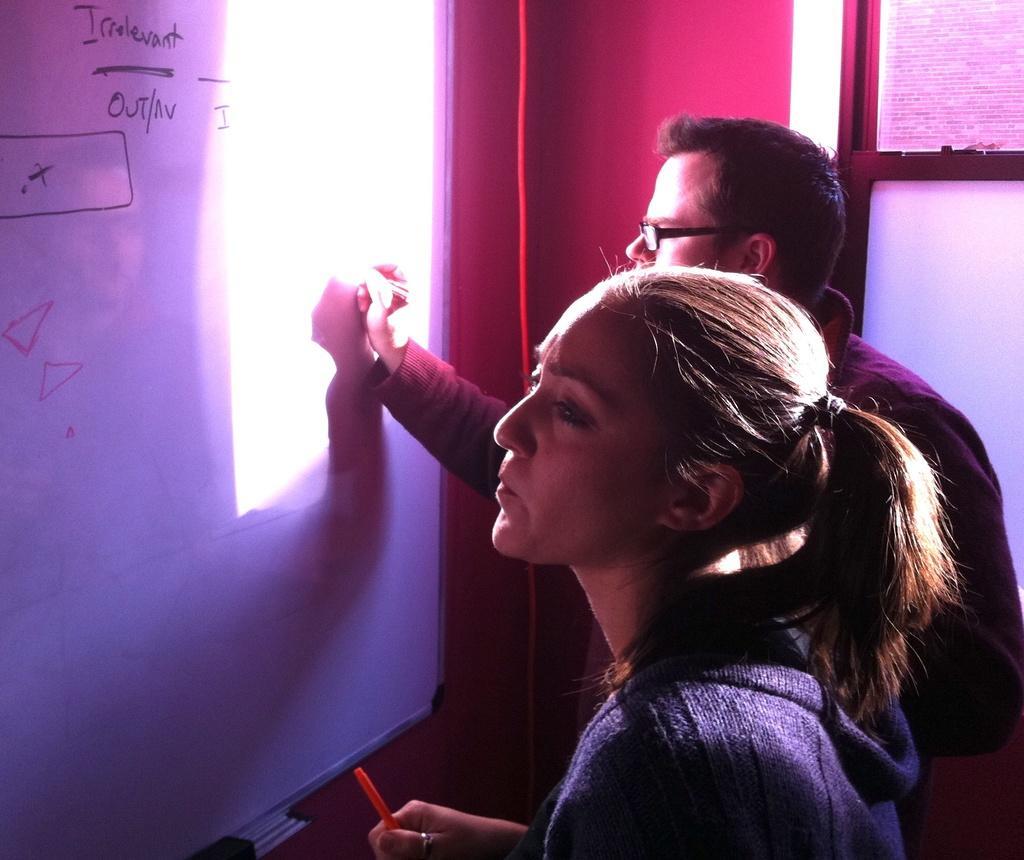Describe this image in one or two sentences. In this image we can see a man and a woman holding the pens and we can also see the man writing on the board. We can also see the text. In the background we can see the wall and also some boards. 